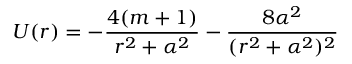<formula> <loc_0><loc_0><loc_500><loc_500>U ( r ) = - { \frac { 4 ( m + 1 ) } { r ^ { 2 } + \alpha ^ { 2 } } } - { \frac { 8 \alpha ^ { 2 } } { ( r ^ { 2 } + \alpha ^ { 2 } ) ^ { 2 } } }</formula> 